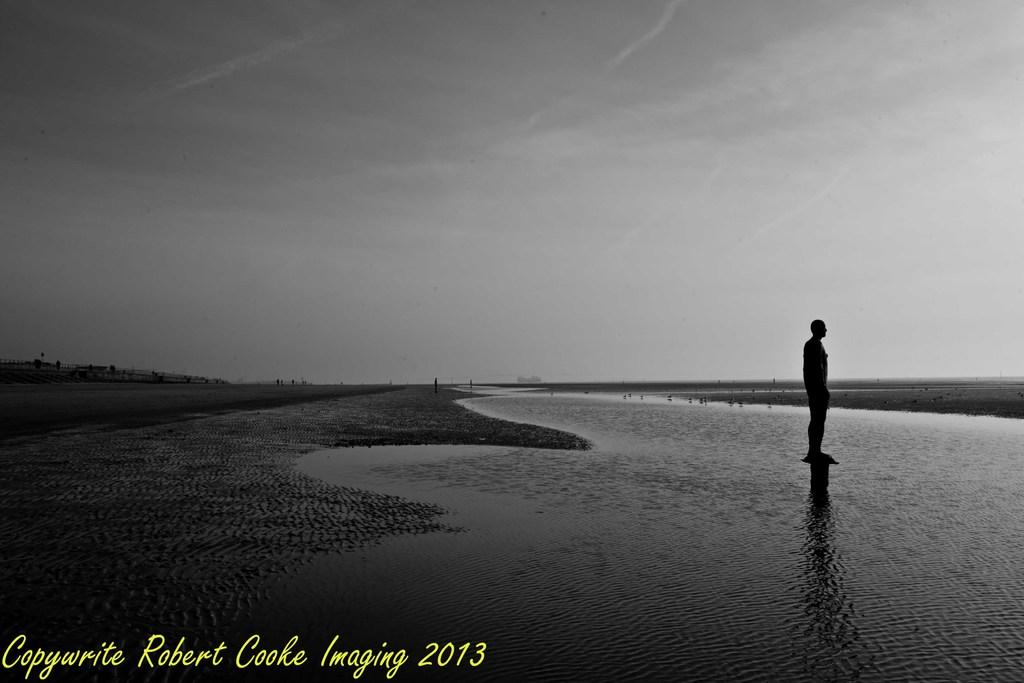What is the color scheme of the image? The image is in black and white. What is the man in the image doing? The man is standing in the river. What can be seen in the background of the image? The sky is visible in the image. What is the condition of the sky in the image? Clouds are present in the sky. Where is the robin perched in the image? There is no robin present in the image. What type of hill can be seen in the background of the image? There is no hill visible in the image; it features a man standing in a river with a sky in the background. 